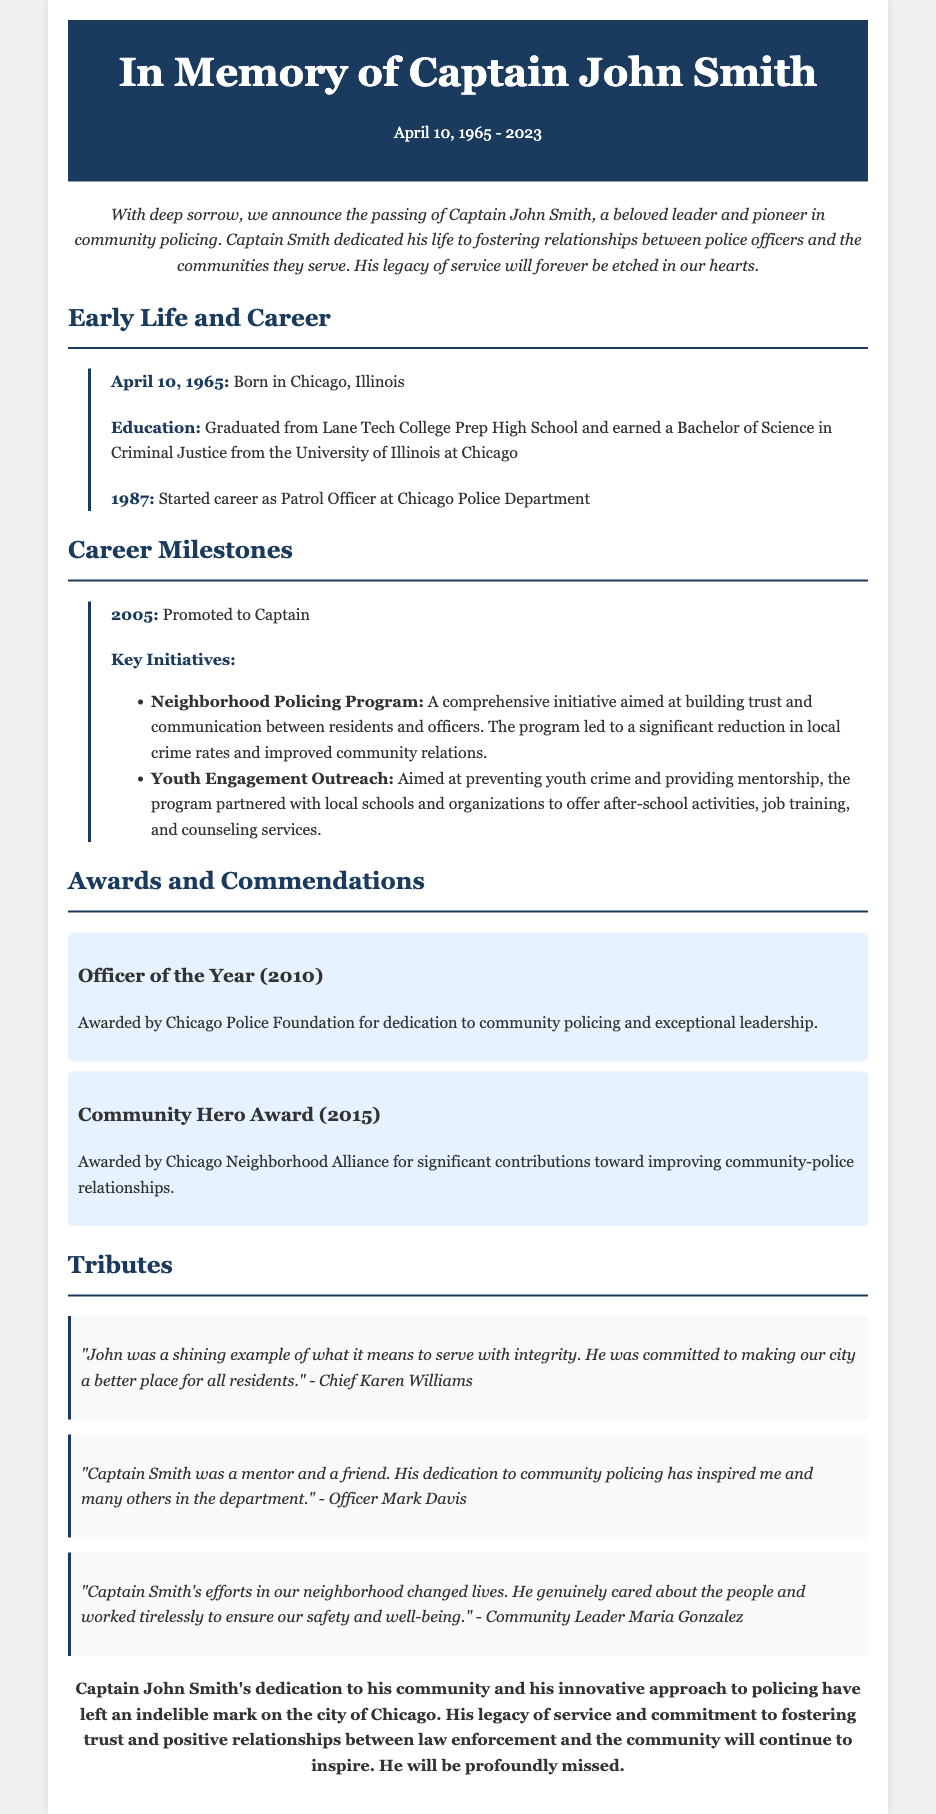What was Captain John Smith's date of birth? The document states that he was born on April 10, 1965.
Answer: April 10, 1965 What award did Captain Smith receive in 2010? The document mentions that he received the Officer of the Year award in 2010.
Answer: Officer of the Year What significant program did Captain Smith initiate? The document highlights the Neighborhood Policing Program as a key initiative he led.
Answer: Neighborhood Policing Program Who awarded Captain Smith the Community Hero Award? According to the document, the Chicago Neighborhood Alliance awarded him the Community Hero Award in 2015.
Answer: Chicago Neighborhood Alliance What was a primary focus of Captain Smith's Youth Engagement Outreach? The document describes the primary focus as preventing youth crime and providing mentorship.
Answer: Preventing youth crime and providing mentorship Which city was Captain John Smith associated with throughout his career? The document clearly states that he served in Chicago, Illinois.
Answer: Chicago What was Captain Smith's role in the police department by 2005? The document indicates that he was promoted to Captain in 2005.
Answer: Captain How is Captain John Smith described in the tributes from Chief Karen Williams? Chief Karen Williams described him as a shining example of what it means to serve with integrity.
Answer: A shining example of what it means to serve with integrity 